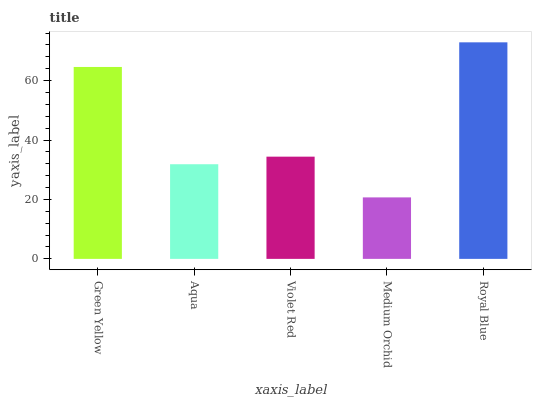Is Medium Orchid the minimum?
Answer yes or no. Yes. Is Royal Blue the maximum?
Answer yes or no. Yes. Is Aqua the minimum?
Answer yes or no. No. Is Aqua the maximum?
Answer yes or no. No. Is Green Yellow greater than Aqua?
Answer yes or no. Yes. Is Aqua less than Green Yellow?
Answer yes or no. Yes. Is Aqua greater than Green Yellow?
Answer yes or no. No. Is Green Yellow less than Aqua?
Answer yes or no. No. Is Violet Red the high median?
Answer yes or no. Yes. Is Violet Red the low median?
Answer yes or no. Yes. Is Royal Blue the high median?
Answer yes or no. No. Is Aqua the low median?
Answer yes or no. No. 